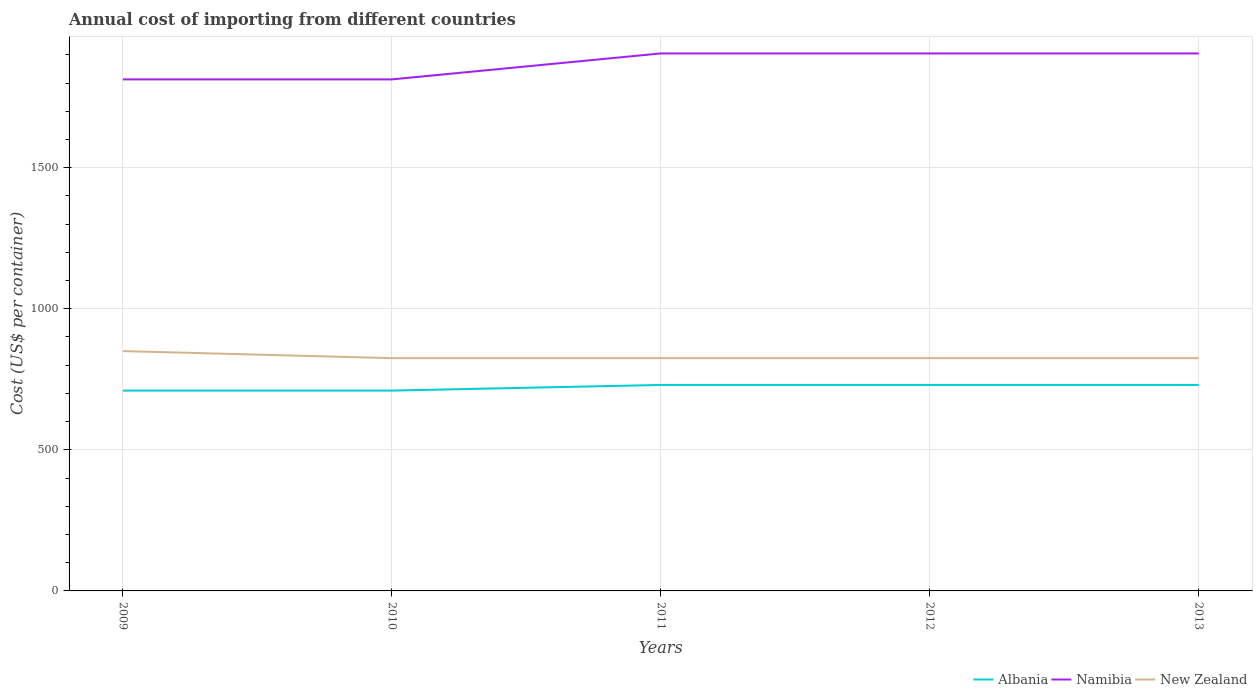How many different coloured lines are there?
Offer a terse response. 3. Is the number of lines equal to the number of legend labels?
Provide a short and direct response. Yes. Across all years, what is the maximum total annual cost of importing in Albania?
Ensure brevity in your answer.  710. In which year was the total annual cost of importing in Namibia maximum?
Offer a very short reply. 2009. What is the total total annual cost of importing in New Zealand in the graph?
Your answer should be very brief. 0. What is the difference between the highest and the second highest total annual cost of importing in Albania?
Give a very brief answer. 20. How many lines are there?
Your response must be concise. 3. How many years are there in the graph?
Ensure brevity in your answer.  5. Are the values on the major ticks of Y-axis written in scientific E-notation?
Offer a terse response. No. Does the graph contain any zero values?
Your answer should be compact. No. Does the graph contain grids?
Provide a succinct answer. Yes. Where does the legend appear in the graph?
Give a very brief answer. Bottom right. What is the title of the graph?
Provide a short and direct response. Annual cost of importing from different countries. What is the label or title of the X-axis?
Your answer should be compact. Years. What is the label or title of the Y-axis?
Ensure brevity in your answer.  Cost (US$ per container). What is the Cost (US$ per container) in Albania in 2009?
Give a very brief answer. 710. What is the Cost (US$ per container) of Namibia in 2009?
Offer a very short reply. 1813. What is the Cost (US$ per container) in New Zealand in 2009?
Make the answer very short. 850. What is the Cost (US$ per container) in Albania in 2010?
Your response must be concise. 710. What is the Cost (US$ per container) of Namibia in 2010?
Give a very brief answer. 1813. What is the Cost (US$ per container) in New Zealand in 2010?
Your response must be concise. 825. What is the Cost (US$ per container) of Albania in 2011?
Your answer should be very brief. 730. What is the Cost (US$ per container) in Namibia in 2011?
Your response must be concise. 1905. What is the Cost (US$ per container) in New Zealand in 2011?
Your response must be concise. 825. What is the Cost (US$ per container) of Albania in 2012?
Make the answer very short. 730. What is the Cost (US$ per container) of Namibia in 2012?
Keep it short and to the point. 1905. What is the Cost (US$ per container) in New Zealand in 2012?
Give a very brief answer. 825. What is the Cost (US$ per container) in Albania in 2013?
Offer a terse response. 730. What is the Cost (US$ per container) in Namibia in 2013?
Your response must be concise. 1905. What is the Cost (US$ per container) in New Zealand in 2013?
Keep it short and to the point. 825. Across all years, what is the maximum Cost (US$ per container) of Albania?
Provide a succinct answer. 730. Across all years, what is the maximum Cost (US$ per container) of Namibia?
Provide a short and direct response. 1905. Across all years, what is the maximum Cost (US$ per container) of New Zealand?
Your response must be concise. 850. Across all years, what is the minimum Cost (US$ per container) in Albania?
Your response must be concise. 710. Across all years, what is the minimum Cost (US$ per container) in Namibia?
Provide a succinct answer. 1813. Across all years, what is the minimum Cost (US$ per container) of New Zealand?
Your answer should be compact. 825. What is the total Cost (US$ per container) of Albania in the graph?
Make the answer very short. 3610. What is the total Cost (US$ per container) of Namibia in the graph?
Your answer should be very brief. 9341. What is the total Cost (US$ per container) in New Zealand in the graph?
Make the answer very short. 4150. What is the difference between the Cost (US$ per container) in Namibia in 2009 and that in 2011?
Offer a terse response. -92. What is the difference between the Cost (US$ per container) in Albania in 2009 and that in 2012?
Your answer should be very brief. -20. What is the difference between the Cost (US$ per container) of Namibia in 2009 and that in 2012?
Offer a very short reply. -92. What is the difference between the Cost (US$ per container) in New Zealand in 2009 and that in 2012?
Provide a succinct answer. 25. What is the difference between the Cost (US$ per container) of Namibia in 2009 and that in 2013?
Give a very brief answer. -92. What is the difference between the Cost (US$ per container) in Namibia in 2010 and that in 2011?
Provide a short and direct response. -92. What is the difference between the Cost (US$ per container) in New Zealand in 2010 and that in 2011?
Ensure brevity in your answer.  0. What is the difference between the Cost (US$ per container) in Namibia in 2010 and that in 2012?
Keep it short and to the point. -92. What is the difference between the Cost (US$ per container) of New Zealand in 2010 and that in 2012?
Keep it short and to the point. 0. What is the difference between the Cost (US$ per container) in Namibia in 2010 and that in 2013?
Offer a terse response. -92. What is the difference between the Cost (US$ per container) in New Zealand in 2010 and that in 2013?
Provide a succinct answer. 0. What is the difference between the Cost (US$ per container) in Albania in 2011 and that in 2012?
Give a very brief answer. 0. What is the difference between the Cost (US$ per container) of Albania in 2011 and that in 2013?
Make the answer very short. 0. What is the difference between the Cost (US$ per container) in Albania in 2012 and that in 2013?
Ensure brevity in your answer.  0. What is the difference between the Cost (US$ per container) of Namibia in 2012 and that in 2013?
Make the answer very short. 0. What is the difference between the Cost (US$ per container) in Albania in 2009 and the Cost (US$ per container) in Namibia in 2010?
Your response must be concise. -1103. What is the difference between the Cost (US$ per container) in Albania in 2009 and the Cost (US$ per container) in New Zealand in 2010?
Offer a very short reply. -115. What is the difference between the Cost (US$ per container) in Namibia in 2009 and the Cost (US$ per container) in New Zealand in 2010?
Offer a very short reply. 988. What is the difference between the Cost (US$ per container) of Albania in 2009 and the Cost (US$ per container) of Namibia in 2011?
Your answer should be compact. -1195. What is the difference between the Cost (US$ per container) in Albania in 2009 and the Cost (US$ per container) in New Zealand in 2011?
Keep it short and to the point. -115. What is the difference between the Cost (US$ per container) of Namibia in 2009 and the Cost (US$ per container) of New Zealand in 2011?
Offer a terse response. 988. What is the difference between the Cost (US$ per container) of Albania in 2009 and the Cost (US$ per container) of Namibia in 2012?
Keep it short and to the point. -1195. What is the difference between the Cost (US$ per container) in Albania in 2009 and the Cost (US$ per container) in New Zealand in 2012?
Keep it short and to the point. -115. What is the difference between the Cost (US$ per container) in Namibia in 2009 and the Cost (US$ per container) in New Zealand in 2012?
Make the answer very short. 988. What is the difference between the Cost (US$ per container) in Albania in 2009 and the Cost (US$ per container) in Namibia in 2013?
Keep it short and to the point. -1195. What is the difference between the Cost (US$ per container) in Albania in 2009 and the Cost (US$ per container) in New Zealand in 2013?
Make the answer very short. -115. What is the difference between the Cost (US$ per container) in Namibia in 2009 and the Cost (US$ per container) in New Zealand in 2013?
Make the answer very short. 988. What is the difference between the Cost (US$ per container) of Albania in 2010 and the Cost (US$ per container) of Namibia in 2011?
Make the answer very short. -1195. What is the difference between the Cost (US$ per container) in Albania in 2010 and the Cost (US$ per container) in New Zealand in 2011?
Keep it short and to the point. -115. What is the difference between the Cost (US$ per container) of Namibia in 2010 and the Cost (US$ per container) of New Zealand in 2011?
Ensure brevity in your answer.  988. What is the difference between the Cost (US$ per container) of Albania in 2010 and the Cost (US$ per container) of Namibia in 2012?
Provide a short and direct response. -1195. What is the difference between the Cost (US$ per container) in Albania in 2010 and the Cost (US$ per container) in New Zealand in 2012?
Your response must be concise. -115. What is the difference between the Cost (US$ per container) in Namibia in 2010 and the Cost (US$ per container) in New Zealand in 2012?
Provide a short and direct response. 988. What is the difference between the Cost (US$ per container) in Albania in 2010 and the Cost (US$ per container) in Namibia in 2013?
Your response must be concise. -1195. What is the difference between the Cost (US$ per container) in Albania in 2010 and the Cost (US$ per container) in New Zealand in 2013?
Your response must be concise. -115. What is the difference between the Cost (US$ per container) of Namibia in 2010 and the Cost (US$ per container) of New Zealand in 2013?
Your answer should be very brief. 988. What is the difference between the Cost (US$ per container) in Albania in 2011 and the Cost (US$ per container) in Namibia in 2012?
Your answer should be very brief. -1175. What is the difference between the Cost (US$ per container) of Albania in 2011 and the Cost (US$ per container) of New Zealand in 2012?
Your answer should be compact. -95. What is the difference between the Cost (US$ per container) of Namibia in 2011 and the Cost (US$ per container) of New Zealand in 2012?
Your answer should be very brief. 1080. What is the difference between the Cost (US$ per container) of Albania in 2011 and the Cost (US$ per container) of Namibia in 2013?
Offer a very short reply. -1175. What is the difference between the Cost (US$ per container) of Albania in 2011 and the Cost (US$ per container) of New Zealand in 2013?
Provide a succinct answer. -95. What is the difference between the Cost (US$ per container) in Namibia in 2011 and the Cost (US$ per container) in New Zealand in 2013?
Give a very brief answer. 1080. What is the difference between the Cost (US$ per container) of Albania in 2012 and the Cost (US$ per container) of Namibia in 2013?
Your response must be concise. -1175. What is the difference between the Cost (US$ per container) in Albania in 2012 and the Cost (US$ per container) in New Zealand in 2013?
Ensure brevity in your answer.  -95. What is the difference between the Cost (US$ per container) of Namibia in 2012 and the Cost (US$ per container) of New Zealand in 2013?
Keep it short and to the point. 1080. What is the average Cost (US$ per container) in Albania per year?
Your response must be concise. 722. What is the average Cost (US$ per container) of Namibia per year?
Ensure brevity in your answer.  1868.2. What is the average Cost (US$ per container) in New Zealand per year?
Ensure brevity in your answer.  830. In the year 2009, what is the difference between the Cost (US$ per container) of Albania and Cost (US$ per container) of Namibia?
Your answer should be compact. -1103. In the year 2009, what is the difference between the Cost (US$ per container) of Albania and Cost (US$ per container) of New Zealand?
Provide a succinct answer. -140. In the year 2009, what is the difference between the Cost (US$ per container) in Namibia and Cost (US$ per container) in New Zealand?
Offer a terse response. 963. In the year 2010, what is the difference between the Cost (US$ per container) of Albania and Cost (US$ per container) of Namibia?
Ensure brevity in your answer.  -1103. In the year 2010, what is the difference between the Cost (US$ per container) of Albania and Cost (US$ per container) of New Zealand?
Give a very brief answer. -115. In the year 2010, what is the difference between the Cost (US$ per container) in Namibia and Cost (US$ per container) in New Zealand?
Your answer should be very brief. 988. In the year 2011, what is the difference between the Cost (US$ per container) of Albania and Cost (US$ per container) of Namibia?
Give a very brief answer. -1175. In the year 2011, what is the difference between the Cost (US$ per container) in Albania and Cost (US$ per container) in New Zealand?
Provide a short and direct response. -95. In the year 2011, what is the difference between the Cost (US$ per container) of Namibia and Cost (US$ per container) of New Zealand?
Your response must be concise. 1080. In the year 2012, what is the difference between the Cost (US$ per container) in Albania and Cost (US$ per container) in Namibia?
Provide a succinct answer. -1175. In the year 2012, what is the difference between the Cost (US$ per container) of Albania and Cost (US$ per container) of New Zealand?
Offer a very short reply. -95. In the year 2012, what is the difference between the Cost (US$ per container) of Namibia and Cost (US$ per container) of New Zealand?
Keep it short and to the point. 1080. In the year 2013, what is the difference between the Cost (US$ per container) of Albania and Cost (US$ per container) of Namibia?
Provide a short and direct response. -1175. In the year 2013, what is the difference between the Cost (US$ per container) in Albania and Cost (US$ per container) in New Zealand?
Your answer should be very brief. -95. In the year 2013, what is the difference between the Cost (US$ per container) in Namibia and Cost (US$ per container) in New Zealand?
Keep it short and to the point. 1080. What is the ratio of the Cost (US$ per container) of Albania in 2009 to that in 2010?
Your response must be concise. 1. What is the ratio of the Cost (US$ per container) in New Zealand in 2009 to that in 2010?
Provide a succinct answer. 1.03. What is the ratio of the Cost (US$ per container) of Albania in 2009 to that in 2011?
Ensure brevity in your answer.  0.97. What is the ratio of the Cost (US$ per container) in Namibia in 2009 to that in 2011?
Offer a terse response. 0.95. What is the ratio of the Cost (US$ per container) in New Zealand in 2009 to that in 2011?
Your answer should be compact. 1.03. What is the ratio of the Cost (US$ per container) of Albania in 2009 to that in 2012?
Your response must be concise. 0.97. What is the ratio of the Cost (US$ per container) in Namibia in 2009 to that in 2012?
Your answer should be very brief. 0.95. What is the ratio of the Cost (US$ per container) of New Zealand in 2009 to that in 2012?
Provide a succinct answer. 1.03. What is the ratio of the Cost (US$ per container) in Albania in 2009 to that in 2013?
Your answer should be compact. 0.97. What is the ratio of the Cost (US$ per container) in Namibia in 2009 to that in 2013?
Your response must be concise. 0.95. What is the ratio of the Cost (US$ per container) in New Zealand in 2009 to that in 2013?
Your response must be concise. 1.03. What is the ratio of the Cost (US$ per container) in Albania in 2010 to that in 2011?
Offer a terse response. 0.97. What is the ratio of the Cost (US$ per container) in Namibia in 2010 to that in 2011?
Make the answer very short. 0.95. What is the ratio of the Cost (US$ per container) in New Zealand in 2010 to that in 2011?
Your answer should be compact. 1. What is the ratio of the Cost (US$ per container) in Albania in 2010 to that in 2012?
Provide a short and direct response. 0.97. What is the ratio of the Cost (US$ per container) in Namibia in 2010 to that in 2012?
Your response must be concise. 0.95. What is the ratio of the Cost (US$ per container) of New Zealand in 2010 to that in 2012?
Make the answer very short. 1. What is the ratio of the Cost (US$ per container) in Albania in 2010 to that in 2013?
Offer a very short reply. 0.97. What is the ratio of the Cost (US$ per container) of Namibia in 2010 to that in 2013?
Offer a very short reply. 0.95. What is the ratio of the Cost (US$ per container) in Namibia in 2011 to that in 2013?
Give a very brief answer. 1. What is the ratio of the Cost (US$ per container) in New Zealand in 2011 to that in 2013?
Your response must be concise. 1. What is the ratio of the Cost (US$ per container) in Namibia in 2012 to that in 2013?
Your response must be concise. 1. What is the ratio of the Cost (US$ per container) of New Zealand in 2012 to that in 2013?
Keep it short and to the point. 1. What is the difference between the highest and the second highest Cost (US$ per container) in Albania?
Provide a succinct answer. 0. What is the difference between the highest and the lowest Cost (US$ per container) in Namibia?
Ensure brevity in your answer.  92. 